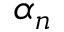<formula> <loc_0><loc_0><loc_500><loc_500>\alpha _ { n }</formula> 